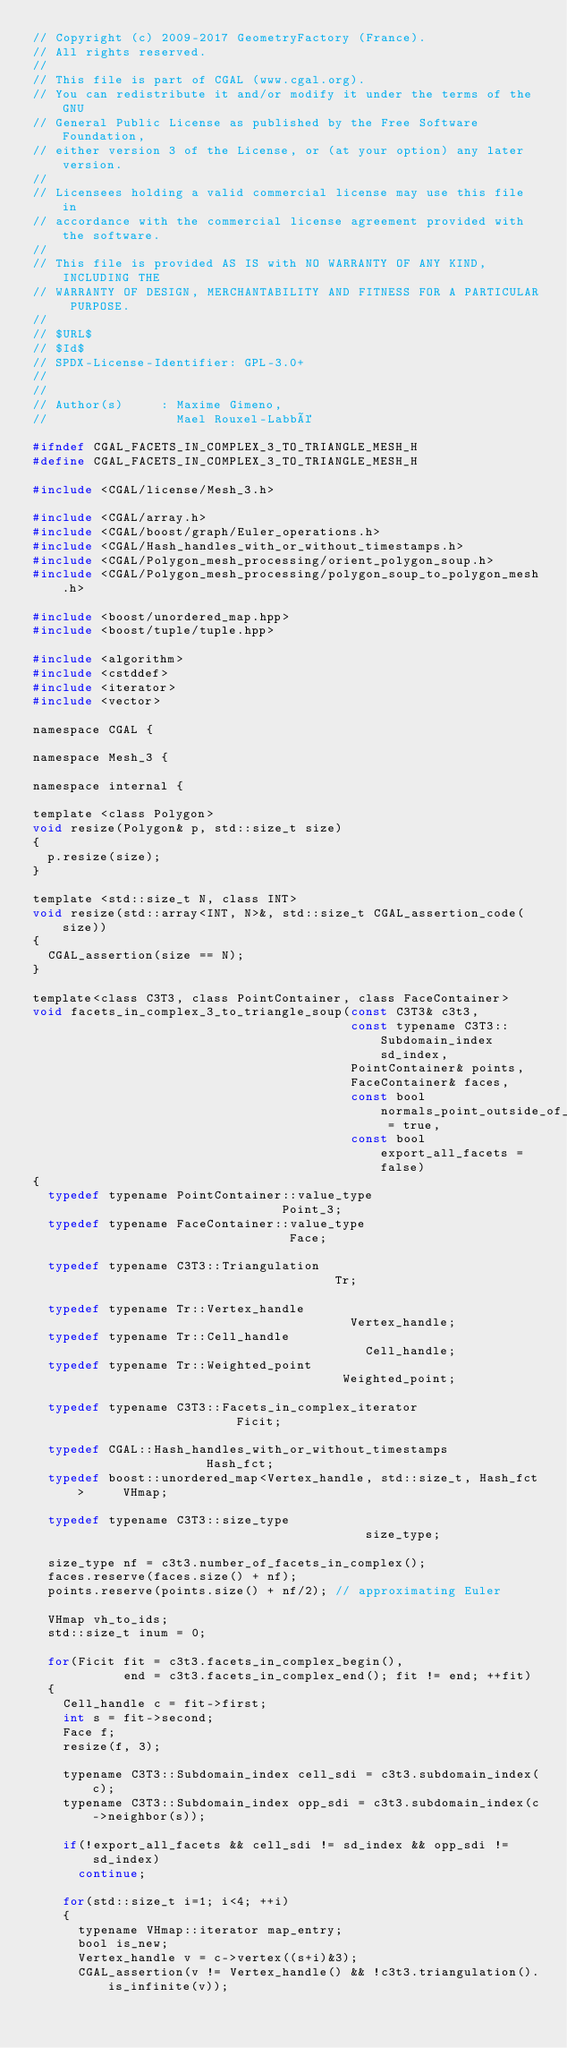<code> <loc_0><loc_0><loc_500><loc_500><_C_>// Copyright (c) 2009-2017 GeometryFactory (France).
// All rights reserved.
//
// This file is part of CGAL (www.cgal.org).
// You can redistribute it and/or modify it under the terms of the GNU
// General Public License as published by the Free Software Foundation,
// either version 3 of the License, or (at your option) any later version.
//
// Licensees holding a valid commercial license may use this file in
// accordance with the commercial license agreement provided with the software.
//
// This file is provided AS IS with NO WARRANTY OF ANY KIND, INCLUDING THE
// WARRANTY OF DESIGN, MERCHANTABILITY AND FITNESS FOR A PARTICULAR PURPOSE.
//
// $URL$
// $Id$
// SPDX-License-Identifier: GPL-3.0+
//
//
// Author(s)     : Maxime Gimeno,
//                 Mael Rouxel-Labbé

#ifndef CGAL_FACETS_IN_COMPLEX_3_TO_TRIANGLE_MESH_H
#define CGAL_FACETS_IN_COMPLEX_3_TO_TRIANGLE_MESH_H

#include <CGAL/license/Mesh_3.h>

#include <CGAL/array.h>
#include <CGAL/boost/graph/Euler_operations.h>
#include <CGAL/Hash_handles_with_or_without_timestamps.h>
#include <CGAL/Polygon_mesh_processing/orient_polygon_soup.h>
#include <CGAL/Polygon_mesh_processing/polygon_soup_to_polygon_mesh.h>

#include <boost/unordered_map.hpp>
#include <boost/tuple/tuple.hpp>

#include <algorithm>
#include <cstddef>
#include <iterator>
#include <vector>

namespace CGAL {

namespace Mesh_3 {

namespace internal {

template <class Polygon>
void resize(Polygon& p, std::size_t size)
{
  p.resize(size);
}

template <std::size_t N, class INT>
void resize(std::array<INT, N>&, std::size_t CGAL_assertion_code(size))
{
  CGAL_assertion(size == N);
}

template<class C3T3, class PointContainer, class FaceContainer>
void facets_in_complex_3_to_triangle_soup(const C3T3& c3t3,
                                          const typename C3T3::Subdomain_index sd_index,
                                          PointContainer& points,
                                          FaceContainer& faces,
                                          const bool normals_point_outside_of_the_subdomain = true,
                                          const bool export_all_facets = false)
{
  typedef typename PointContainer::value_type                            Point_3;
  typedef typename FaceContainer::value_type                             Face;

  typedef typename C3T3::Triangulation                                   Tr;

  typedef typename Tr::Vertex_handle                                     Vertex_handle;
  typedef typename Tr::Cell_handle                                       Cell_handle;
  typedef typename Tr::Weighted_point                                    Weighted_point;

  typedef typename C3T3::Facets_in_complex_iterator                      Ficit;

  typedef CGAL::Hash_handles_with_or_without_timestamps                  Hash_fct;
  typedef boost::unordered_map<Vertex_handle, std::size_t, Hash_fct>     VHmap;

  typedef typename C3T3::size_type                                       size_type;

  size_type nf = c3t3.number_of_facets_in_complex();
  faces.reserve(faces.size() + nf);
  points.reserve(points.size() + nf/2); // approximating Euler

  VHmap vh_to_ids;
  std::size_t inum = 0;

  for(Ficit fit = c3t3.facets_in_complex_begin(),
            end = c3t3.facets_in_complex_end(); fit != end; ++fit)
  {
    Cell_handle c = fit->first;
    int s = fit->second;
    Face f;
    resize(f, 3);

    typename C3T3::Subdomain_index cell_sdi = c3t3.subdomain_index(c);
    typename C3T3::Subdomain_index opp_sdi = c3t3.subdomain_index(c->neighbor(s));

    if(!export_all_facets && cell_sdi != sd_index && opp_sdi != sd_index)
      continue;

    for(std::size_t i=1; i<4; ++i)
    {
      typename VHmap::iterator map_entry;
      bool is_new;
      Vertex_handle v = c->vertex((s+i)&3);
      CGAL_assertion(v != Vertex_handle() && !c3t3.triangulation().is_infinite(v));
</code> 